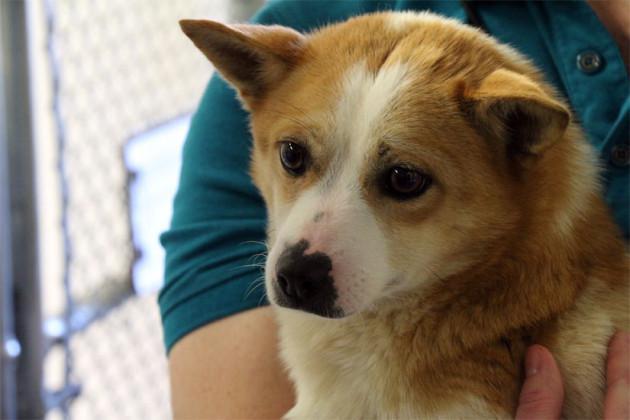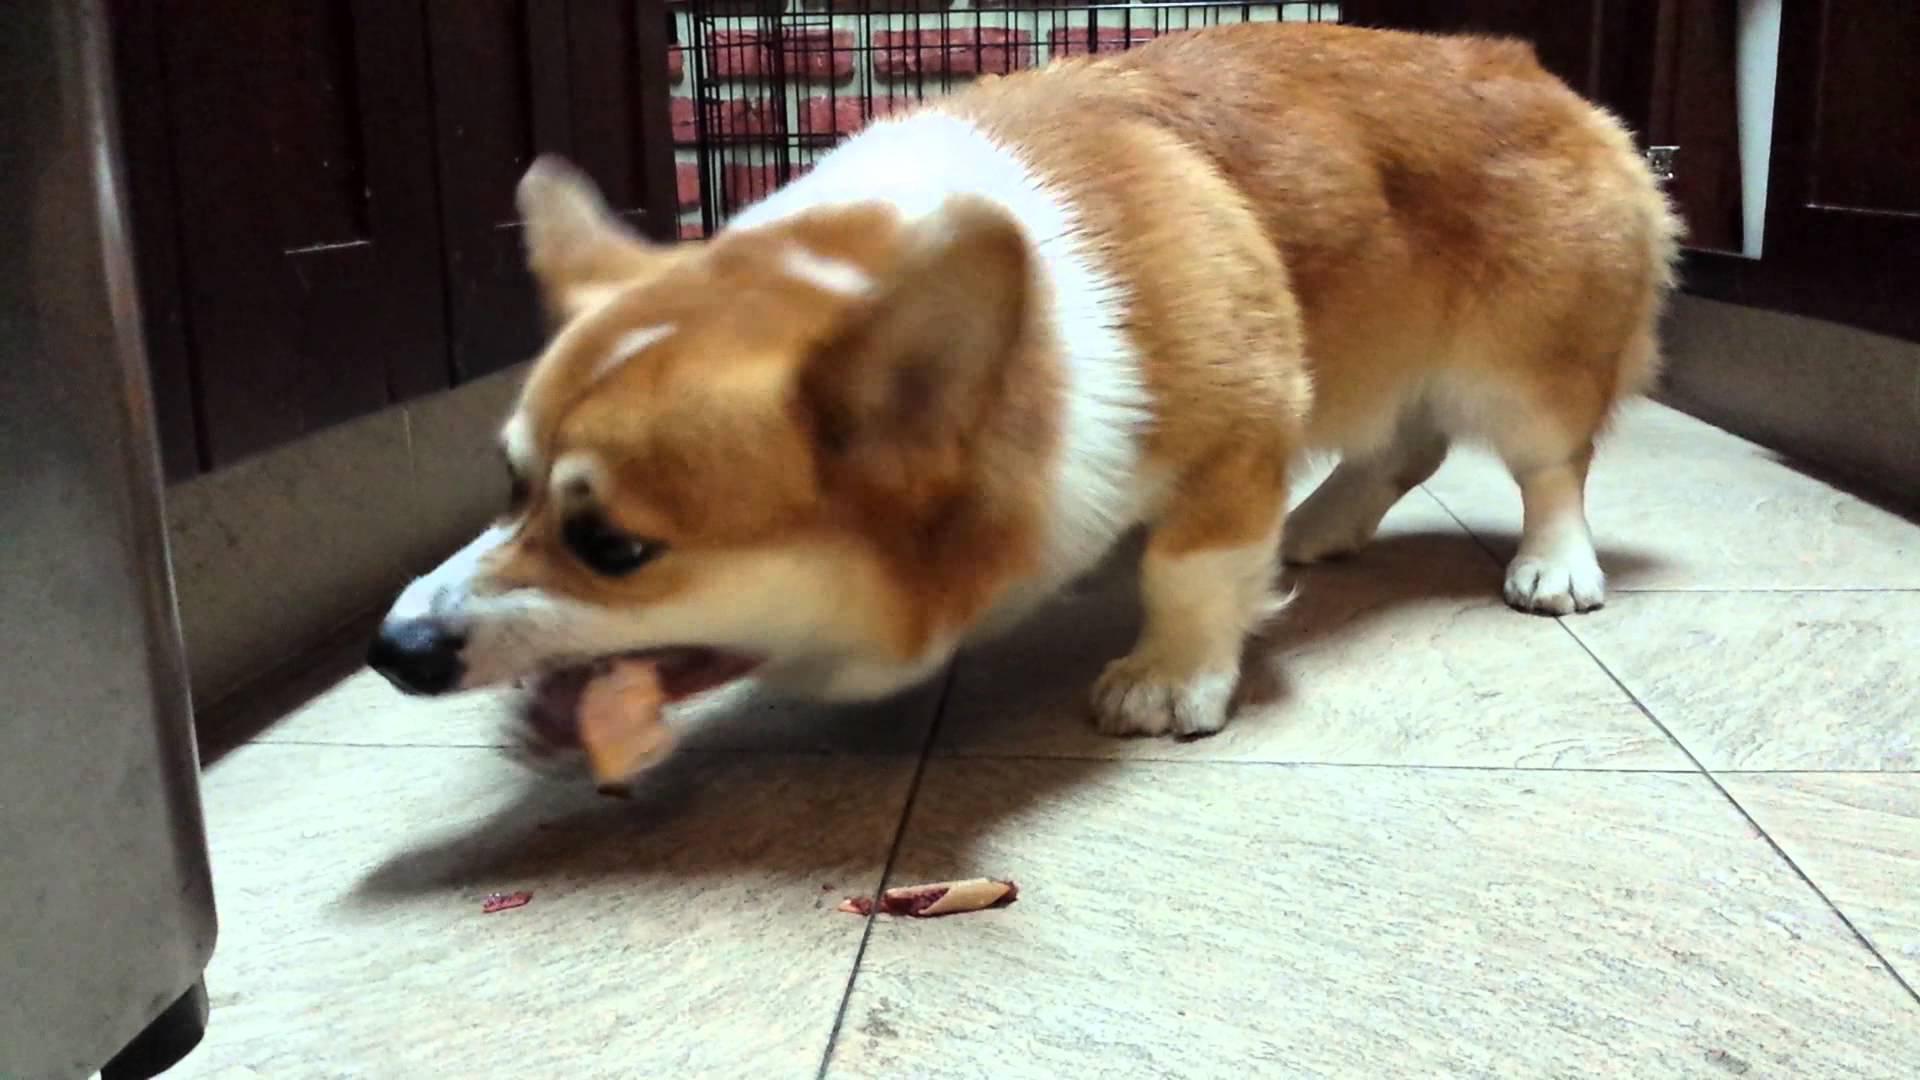The first image is the image on the left, the second image is the image on the right. Considering the images on both sides, is "there is a dog and a chicken  in a dirt yard" valid? Answer yes or no. No. The first image is the image on the left, the second image is the image on the right. Evaluate the accuracy of this statement regarding the images: "In one of the images there is a dog facing a chicken.". Is it true? Answer yes or no. No. 